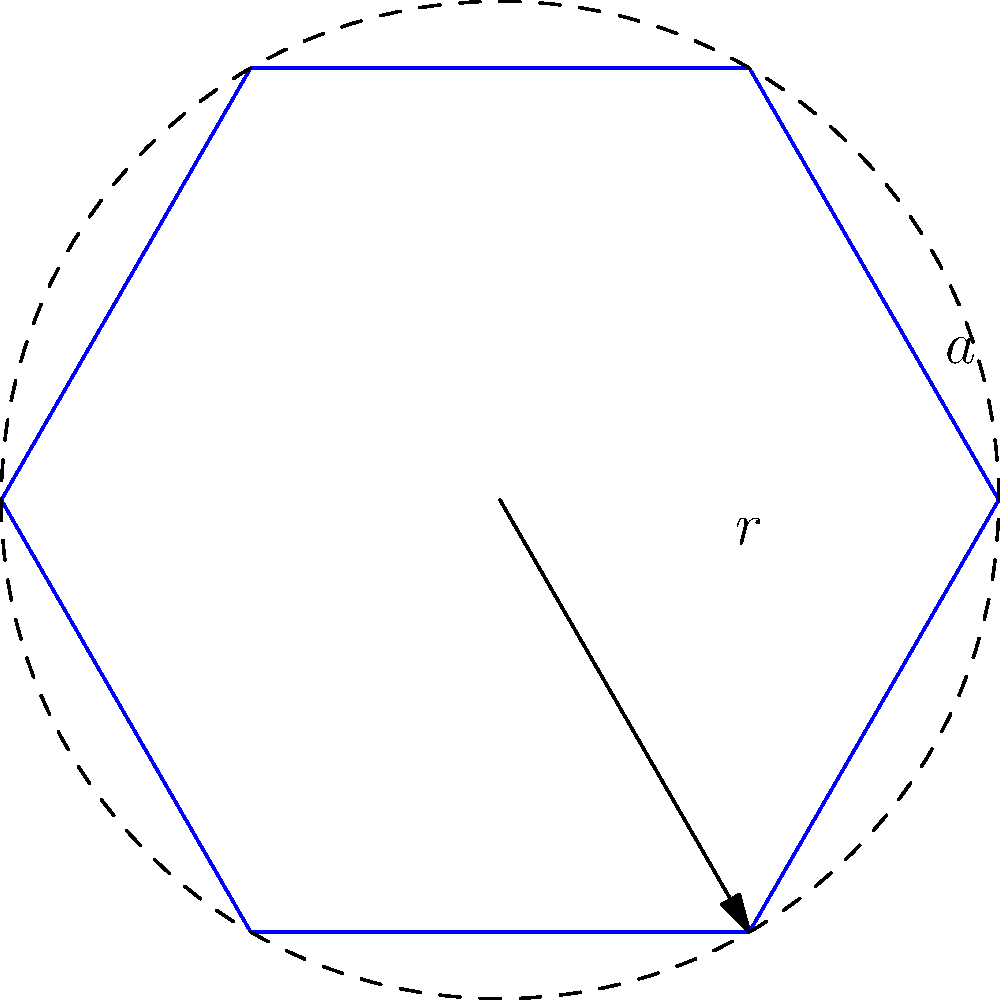A hexagonal snow crystal has a side length of 0.1 mm. Calculate its surface area and explain how this affects its ability to reflect light compared to a circular snowflake of the same radius. How might this impact your observations of winter light phenomena in Canada? Let's approach this step-by-step:

1) For a regular hexagon, the relationship between side length $a$ and radius $r$ is:
   $r = a \cdot \frac{\sqrt{3}}{2}$

2) Given $a = 0.1$ mm, we can calculate $r$:
   $r = 0.1 \cdot \frac{\sqrt{3}}{2} \approx 0.0866$ mm

3) The area of a regular hexagon is:
   $A_{hex} = \frac{3\sqrt{3}}{2}a^2$

4) Substituting $a = 0.1$ mm:
   $A_{hex} = \frac{3\sqrt{3}}{2}(0.1)^2 \approx 0.0259$ mm²

5) For comparison, the area of a circle with the same radius:
   $A_{circle} = \pi r^2 = \pi(0.0866)^2 \approx 0.0236$ mm²

6) The hexagonal crystal has about 9.7% more surface area than a circular one of the same radius.

7) More surface area means more facets for light reflection, potentially increasing the crystal's albedo (reflectivity).

8) In Canadian winters, this could contribute to:
   - Enhanced brightness of snow-covered landscapes
   - Increased likelihood of optical phenomena like sun dogs or light pillars
   - Potentially more intense "diamond dust" effect on very cold, clear days

9) For weather scientists, this underscores the importance of crystal shape in modeling winter light phenomena and overall reflectivity of snowpack, which can affect local temperature patterns and climate models.
Answer: Surface area ≈ 0.0259 mm²; hexagonal shape increases light reflection compared to circular, enhancing winter light phenomena. 